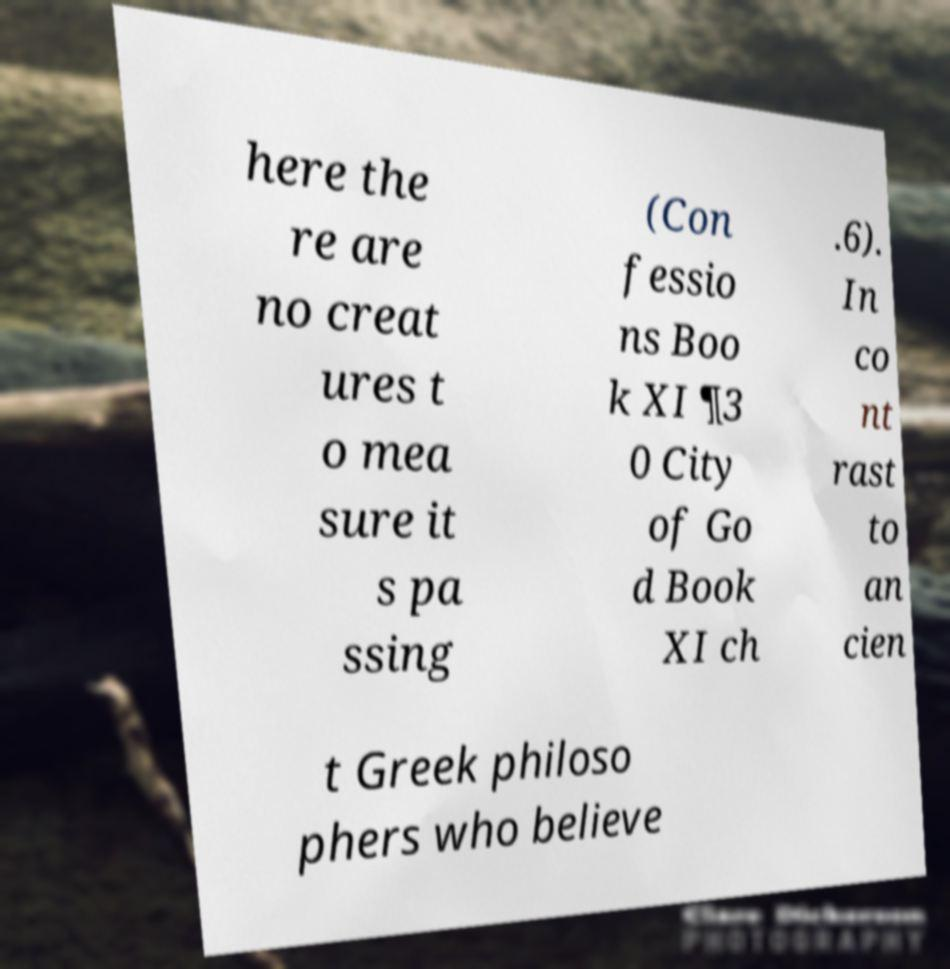Can you accurately transcribe the text from the provided image for me? here the re are no creat ures t o mea sure it s pa ssing (Con fessio ns Boo k XI ¶3 0 City of Go d Book XI ch .6). In co nt rast to an cien t Greek philoso phers who believe 